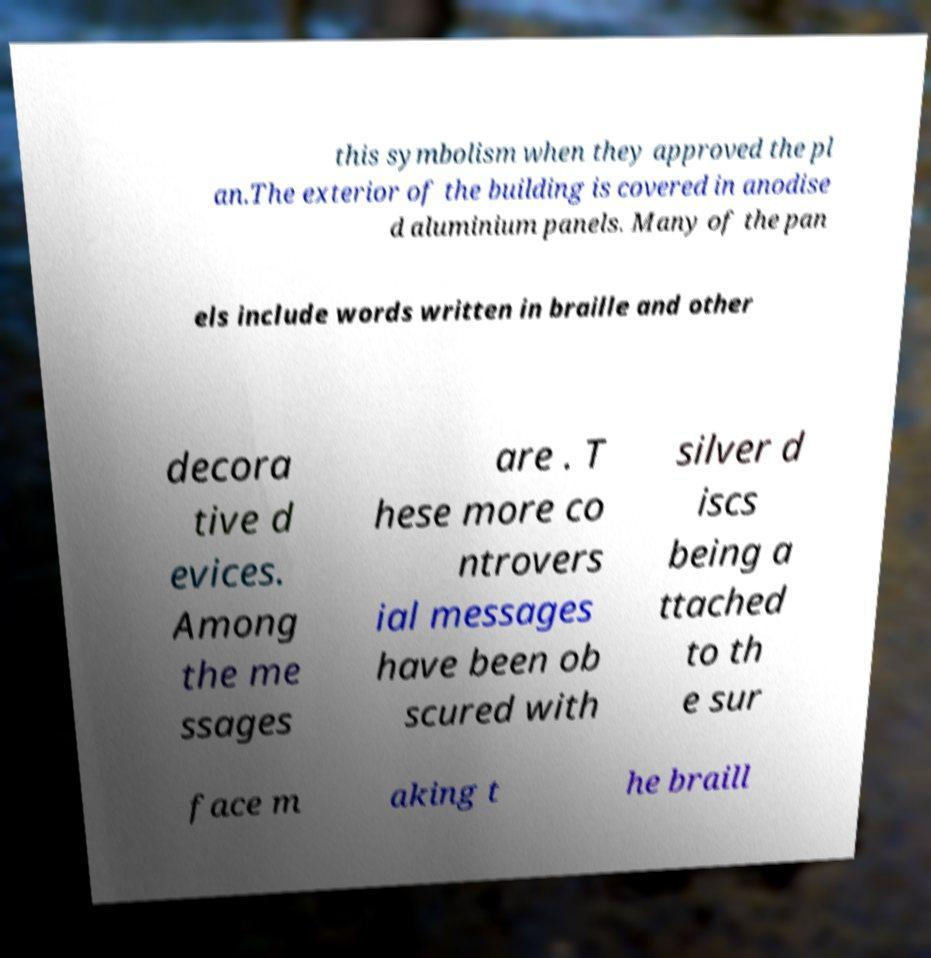Please read and relay the text visible in this image. What does it say? this symbolism when they approved the pl an.The exterior of the building is covered in anodise d aluminium panels. Many of the pan els include words written in braille and other decora tive d evices. Among the me ssages are . T hese more co ntrovers ial messages have been ob scured with silver d iscs being a ttached to th e sur face m aking t he braill 